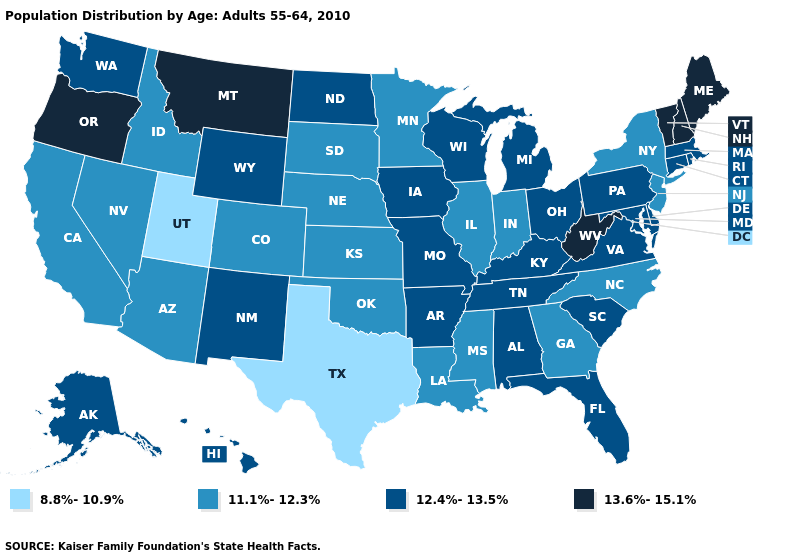What is the highest value in states that border Wisconsin?
Keep it brief. 12.4%-13.5%. What is the highest value in the MidWest ?
Be succinct. 12.4%-13.5%. What is the value of Oregon?
Concise answer only. 13.6%-15.1%. Name the states that have a value in the range 8.8%-10.9%?
Give a very brief answer. Texas, Utah. What is the lowest value in the USA?
Concise answer only. 8.8%-10.9%. Does West Virginia have the same value as Oregon?
Give a very brief answer. Yes. What is the value of Louisiana?
Short answer required. 11.1%-12.3%. Does Utah have the lowest value in the USA?
Keep it brief. Yes. Which states hav the highest value in the West?
Keep it brief. Montana, Oregon. Name the states that have a value in the range 13.6%-15.1%?
Answer briefly. Maine, Montana, New Hampshire, Oregon, Vermont, West Virginia. How many symbols are there in the legend?
Quick response, please. 4. Name the states that have a value in the range 12.4%-13.5%?
Answer briefly. Alabama, Alaska, Arkansas, Connecticut, Delaware, Florida, Hawaii, Iowa, Kentucky, Maryland, Massachusetts, Michigan, Missouri, New Mexico, North Dakota, Ohio, Pennsylvania, Rhode Island, South Carolina, Tennessee, Virginia, Washington, Wisconsin, Wyoming. Name the states that have a value in the range 8.8%-10.9%?
Answer briefly. Texas, Utah. What is the value of Massachusetts?
Write a very short answer. 12.4%-13.5%. What is the lowest value in states that border Delaware?
Short answer required. 11.1%-12.3%. 